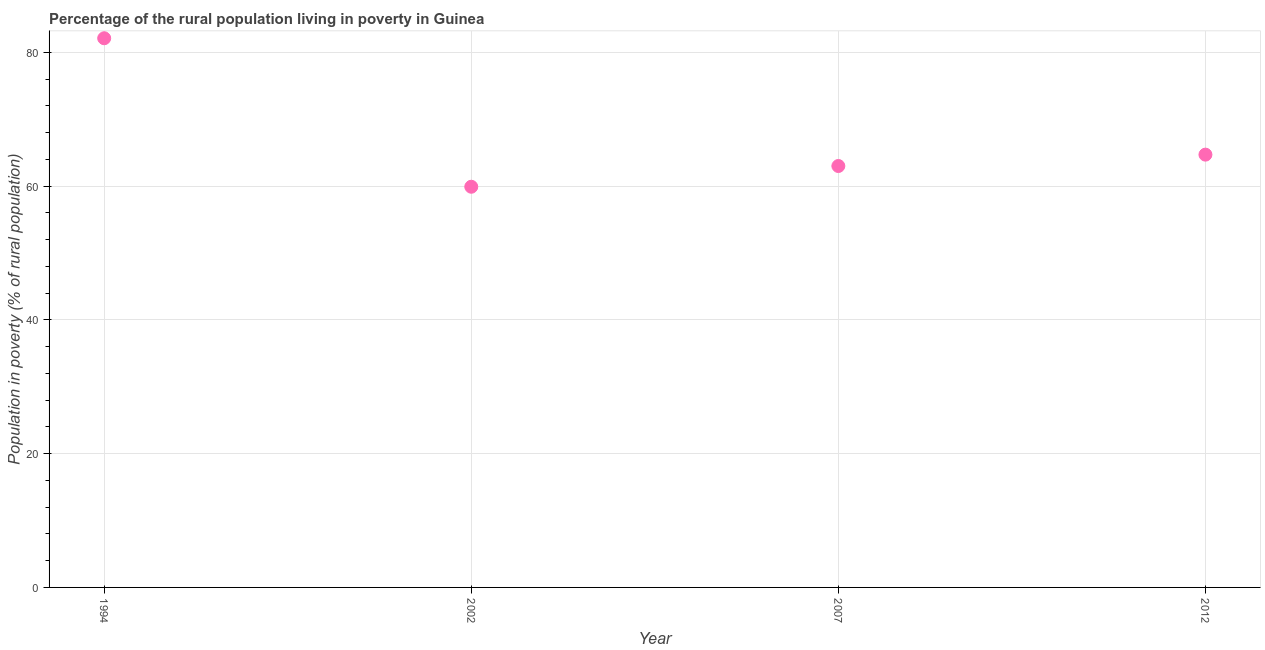What is the percentage of rural population living below poverty line in 2002?
Make the answer very short. 59.9. Across all years, what is the maximum percentage of rural population living below poverty line?
Your answer should be compact. 82.1. Across all years, what is the minimum percentage of rural population living below poverty line?
Your answer should be very brief. 59.9. In which year was the percentage of rural population living below poverty line maximum?
Your response must be concise. 1994. What is the sum of the percentage of rural population living below poverty line?
Your answer should be compact. 269.7. What is the difference between the percentage of rural population living below poverty line in 2007 and 2012?
Offer a very short reply. -1.7. What is the average percentage of rural population living below poverty line per year?
Offer a very short reply. 67.42. What is the median percentage of rural population living below poverty line?
Keep it short and to the point. 63.85. What is the ratio of the percentage of rural population living below poverty line in 2002 to that in 2012?
Offer a terse response. 0.93. Is the difference between the percentage of rural population living below poverty line in 1994 and 2012 greater than the difference between any two years?
Keep it short and to the point. No. What is the difference between the highest and the second highest percentage of rural population living below poverty line?
Give a very brief answer. 17.4. What is the difference between the highest and the lowest percentage of rural population living below poverty line?
Your answer should be very brief. 22.2. In how many years, is the percentage of rural population living below poverty line greater than the average percentage of rural population living below poverty line taken over all years?
Your answer should be compact. 1. How many years are there in the graph?
Provide a succinct answer. 4. What is the difference between two consecutive major ticks on the Y-axis?
Keep it short and to the point. 20. Does the graph contain any zero values?
Ensure brevity in your answer.  No. What is the title of the graph?
Your answer should be compact. Percentage of the rural population living in poverty in Guinea. What is the label or title of the Y-axis?
Provide a succinct answer. Population in poverty (% of rural population). What is the Population in poverty (% of rural population) in 1994?
Offer a very short reply. 82.1. What is the Population in poverty (% of rural population) in 2002?
Offer a terse response. 59.9. What is the Population in poverty (% of rural population) in 2007?
Give a very brief answer. 63. What is the Population in poverty (% of rural population) in 2012?
Your answer should be compact. 64.7. What is the difference between the Population in poverty (% of rural population) in 2002 and 2007?
Your response must be concise. -3.1. What is the ratio of the Population in poverty (% of rural population) in 1994 to that in 2002?
Ensure brevity in your answer.  1.37. What is the ratio of the Population in poverty (% of rural population) in 1994 to that in 2007?
Your answer should be compact. 1.3. What is the ratio of the Population in poverty (% of rural population) in 1994 to that in 2012?
Provide a short and direct response. 1.27. What is the ratio of the Population in poverty (% of rural population) in 2002 to that in 2007?
Provide a succinct answer. 0.95. What is the ratio of the Population in poverty (% of rural population) in 2002 to that in 2012?
Give a very brief answer. 0.93. 